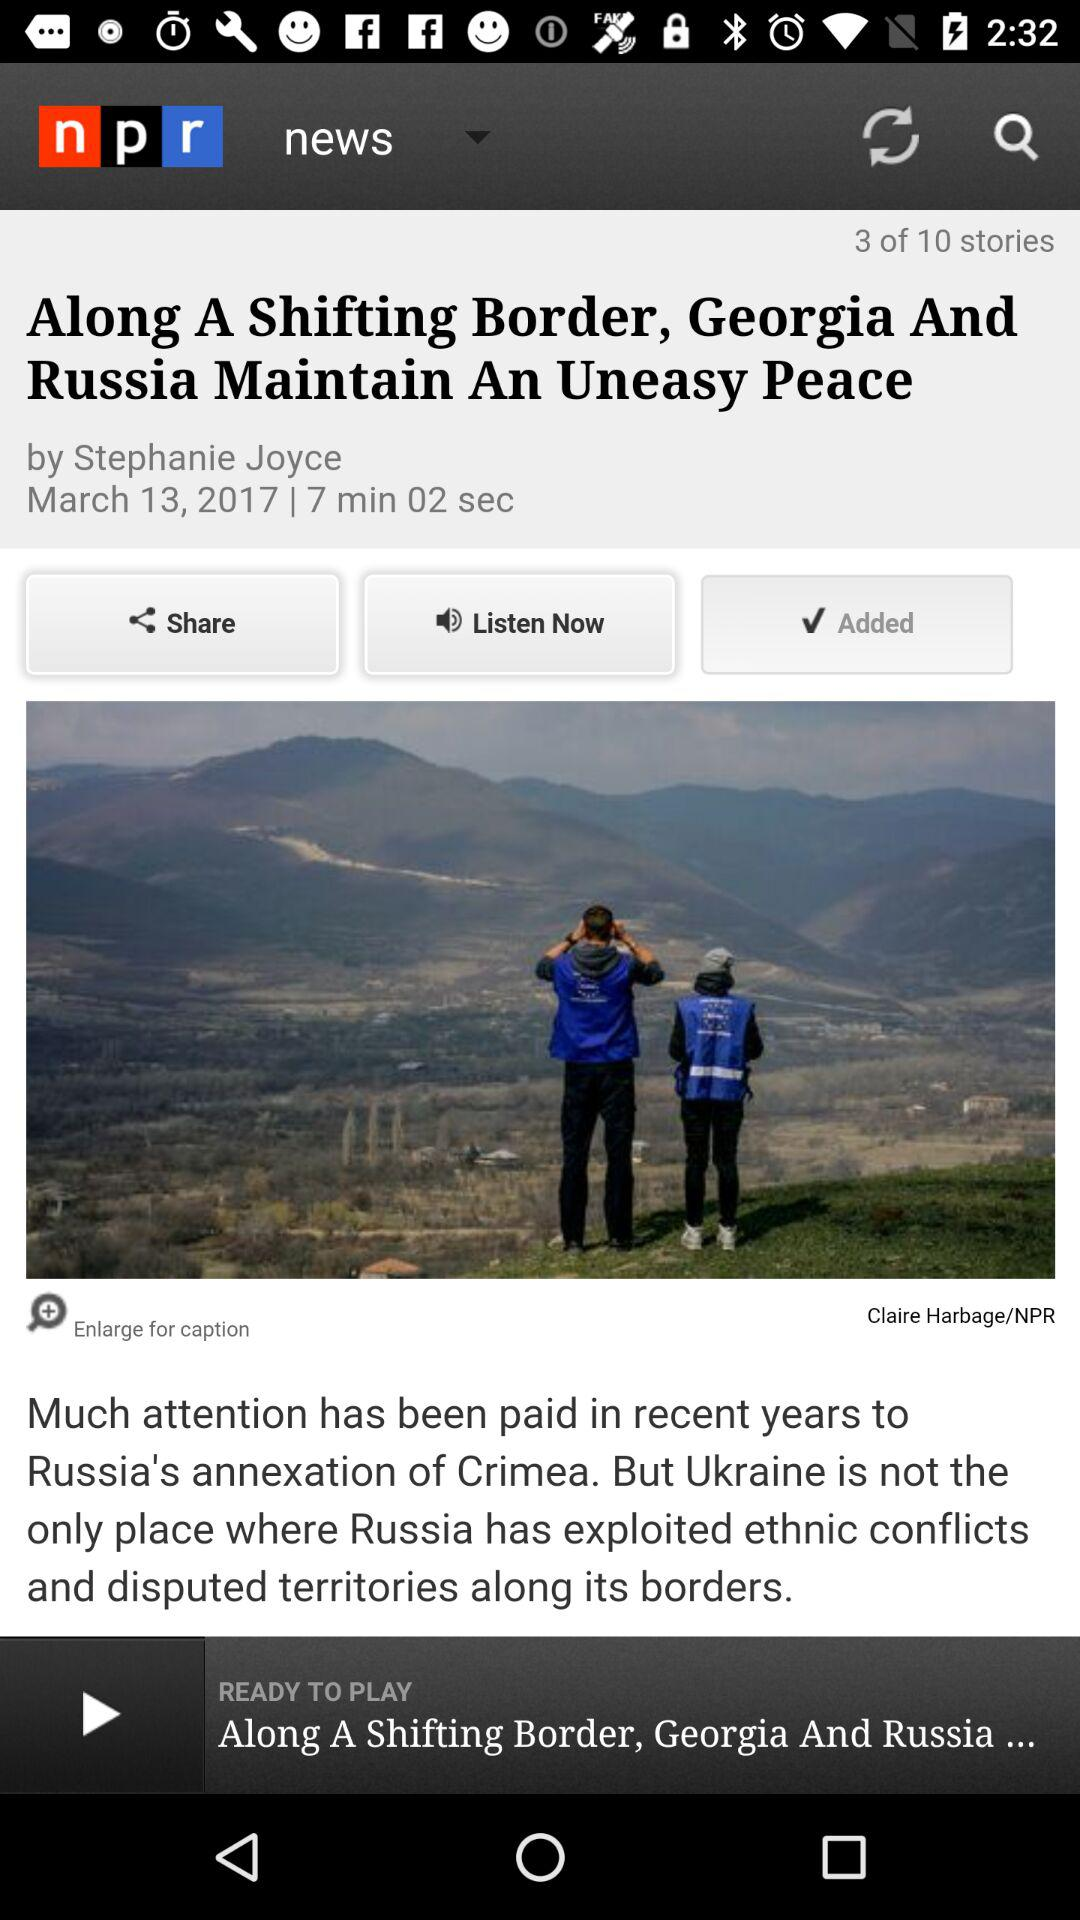How many stories are shown here? There are 10 stories. 